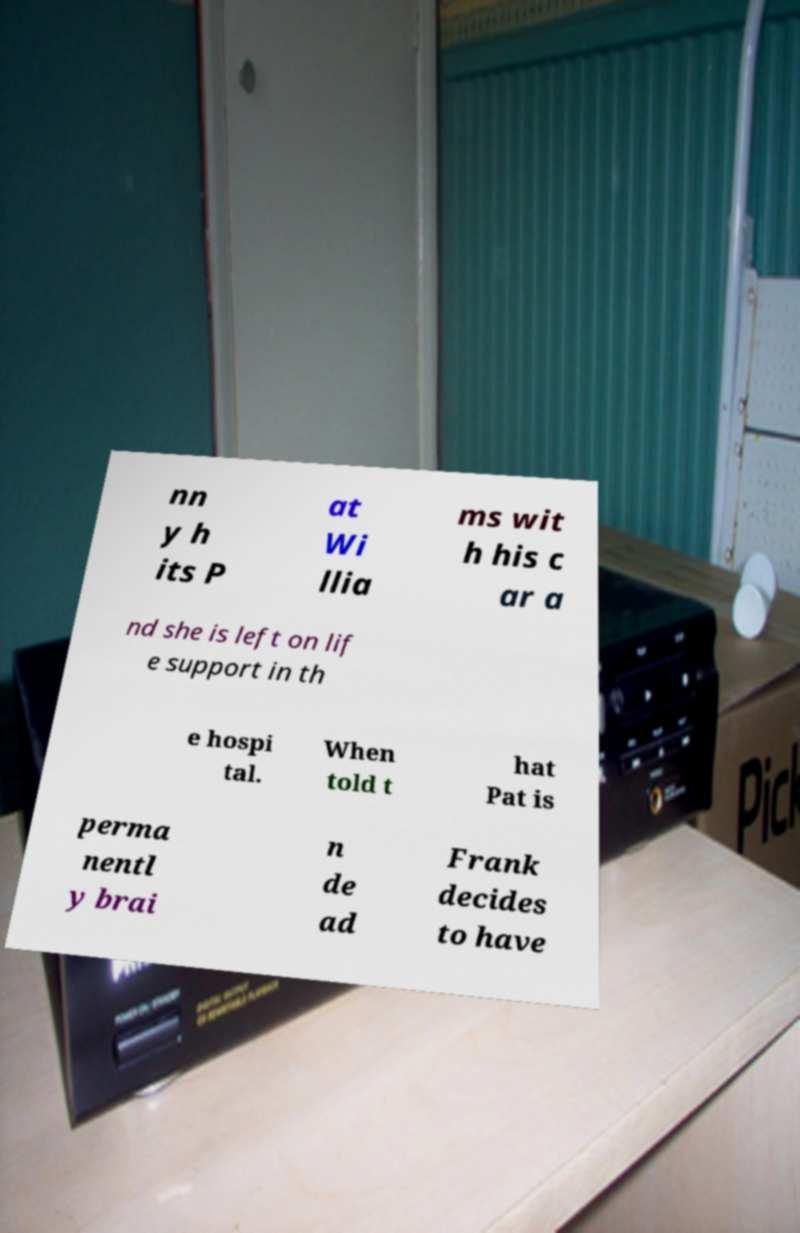Please read and relay the text visible in this image. What does it say? nn y h its P at Wi llia ms wit h his c ar a nd she is left on lif e support in th e hospi tal. When told t hat Pat is perma nentl y brai n de ad Frank decides to have 